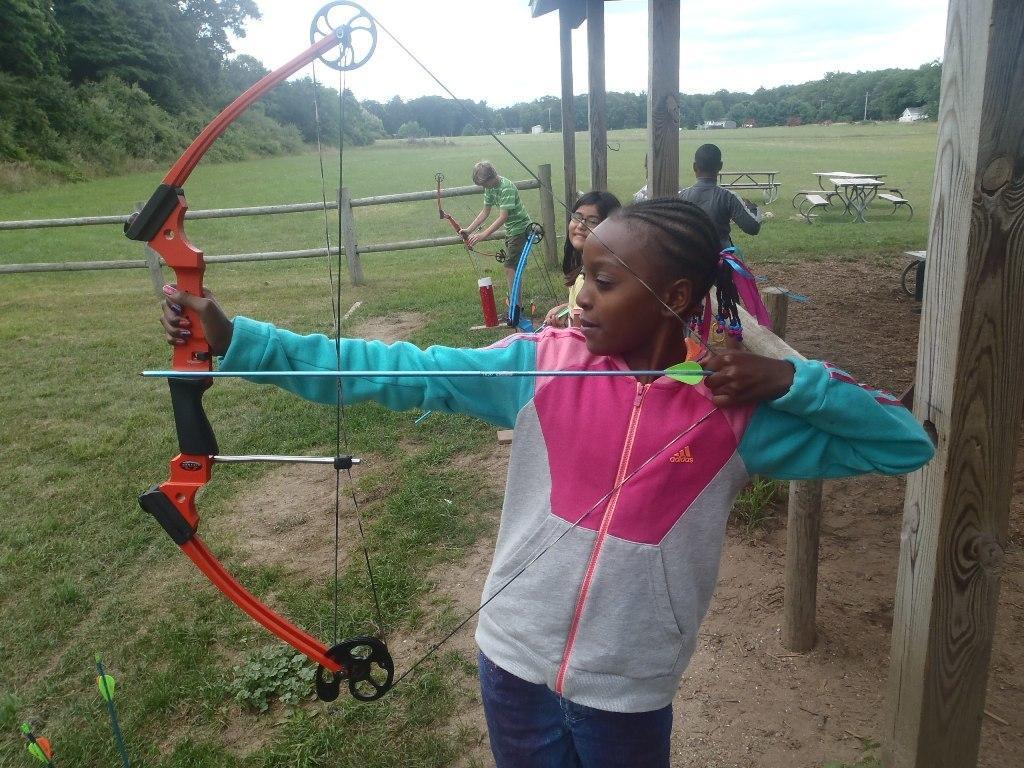Describe this image in one or two sentences. In the foreground of the picture there are arrows, pole, grass, plants and a girl holding bow and arrow. In the center of the picture there are benches, kids, wooden poles, fencing, arrows, soil, grass and other objects. In the background there are trees, buildings, grass and sky. 